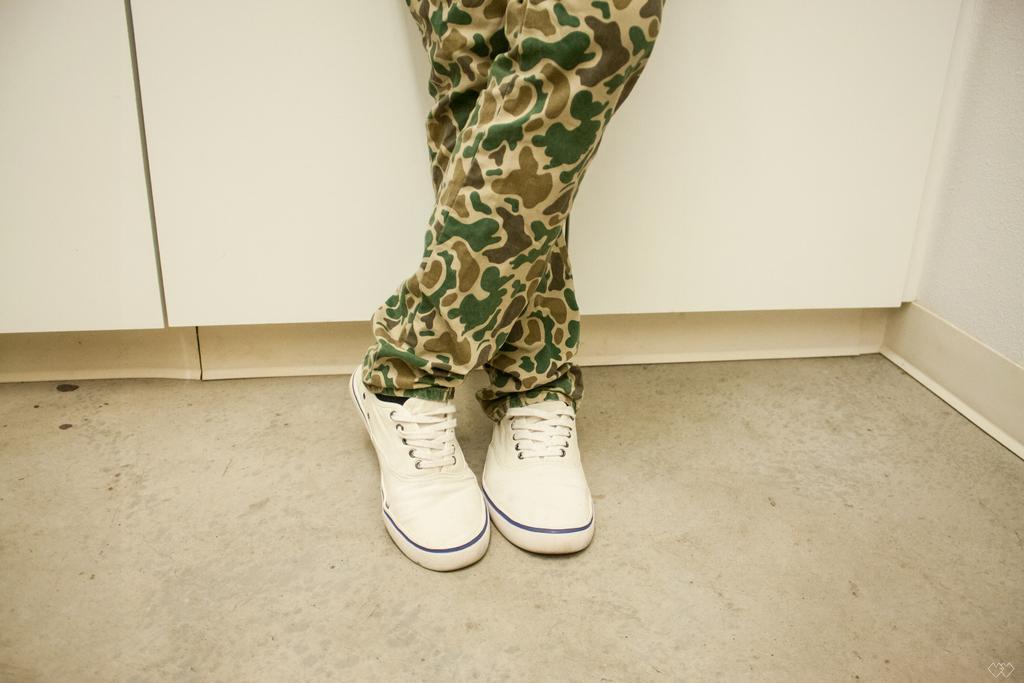How would you summarize this image in a sentence or two? Here in this picture we can see a person's legs present on the floor over there and we can see white colored shoes on the legs over there. 